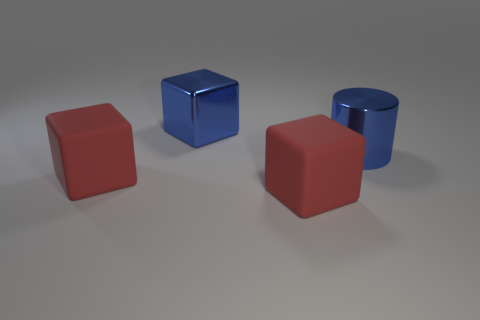The metal cube that is the same size as the blue cylinder is what color?
Provide a succinct answer. Blue. Is there a big cylinder of the same color as the metallic block?
Your answer should be compact. Yes. How many things are big things in front of the big cylinder or tiny red objects?
Give a very brief answer. 2. How many other things are there of the same size as the shiny cylinder?
Offer a very short reply. 3. What material is the blue thing that is right of the large rubber block that is right of the blue thing that is behind the big blue metallic cylinder?
Keep it short and to the point. Metal. How many cylinders are either big things or large blue things?
Offer a very short reply. 1. Is the number of large blue objects that are to the right of the metallic cylinder greater than the number of shiny blocks that are left of the big blue metallic block?
Keep it short and to the point. No. There is a blue object right of the big metallic block; how many shiny blocks are in front of it?
Keep it short and to the point. 0. How many objects are large cylinders or big red matte things?
Ensure brevity in your answer.  3. What is the material of the large blue block?
Ensure brevity in your answer.  Metal. 